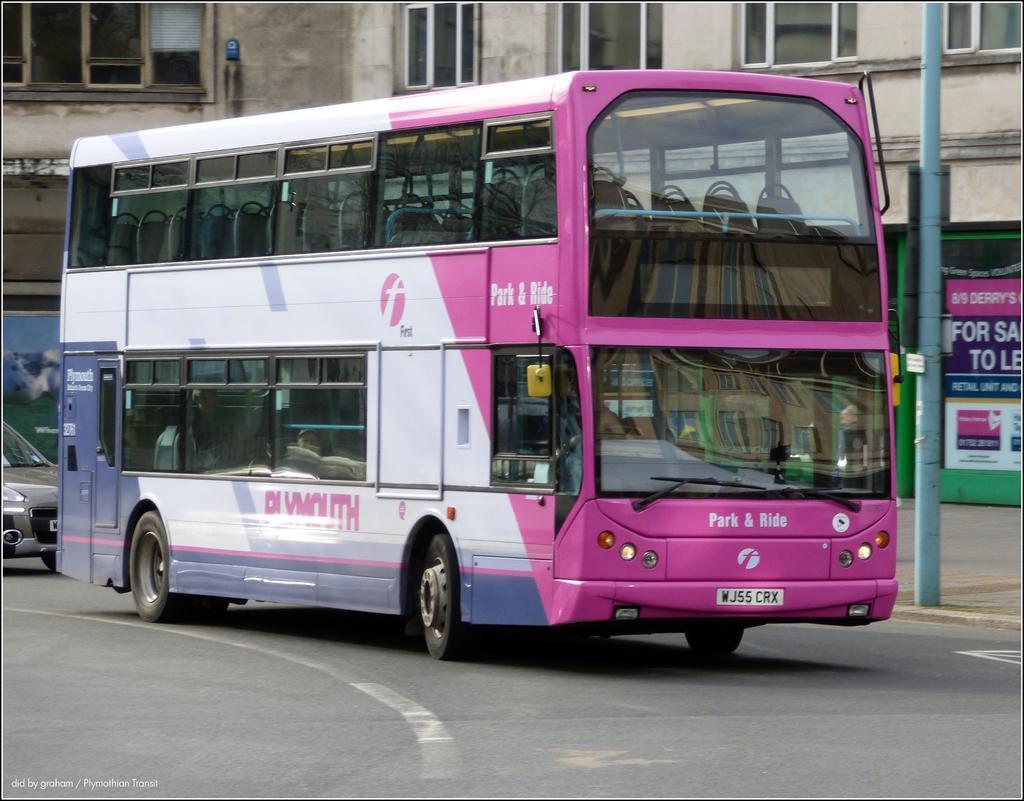How would you summarize this image in a sentence or two? In the center of the image we can see a double decker bus. On the left side of the image we can see a car. In the background of the image we can see the buildings, windows, wall, pole, boards. At the bottom of the image we can see the road. In the bottom left corner we can see the text. 